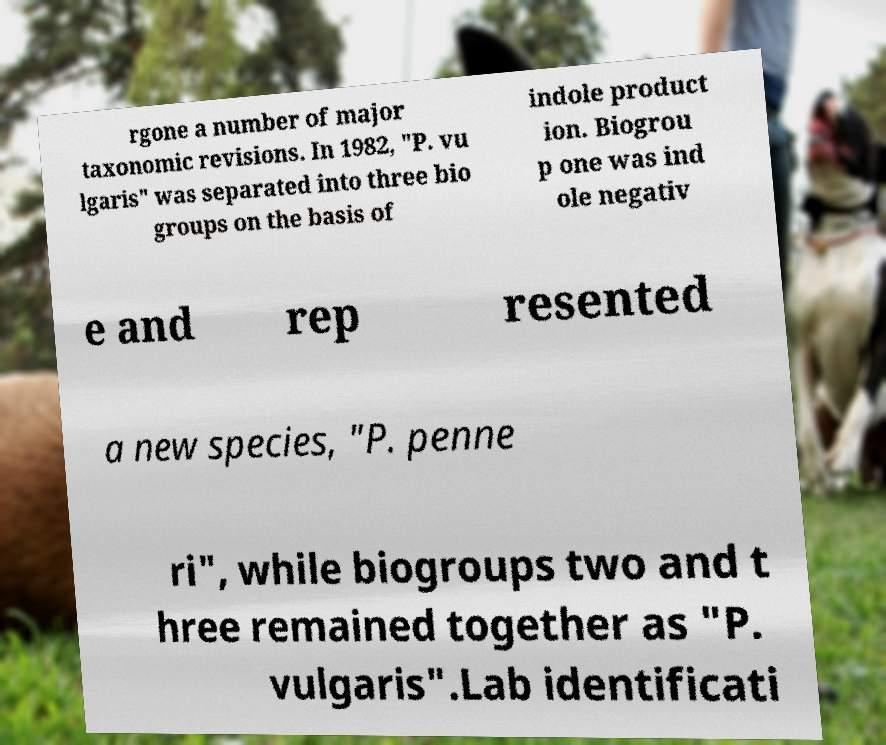Could you assist in decoding the text presented in this image and type it out clearly? rgone a number of major taxonomic revisions. In 1982, "P. vu lgaris" was separated into three bio groups on the basis of indole product ion. Biogrou p one was ind ole negativ e and rep resented a new species, "P. penne ri", while biogroups two and t hree remained together as "P. vulgaris".Lab identificati 